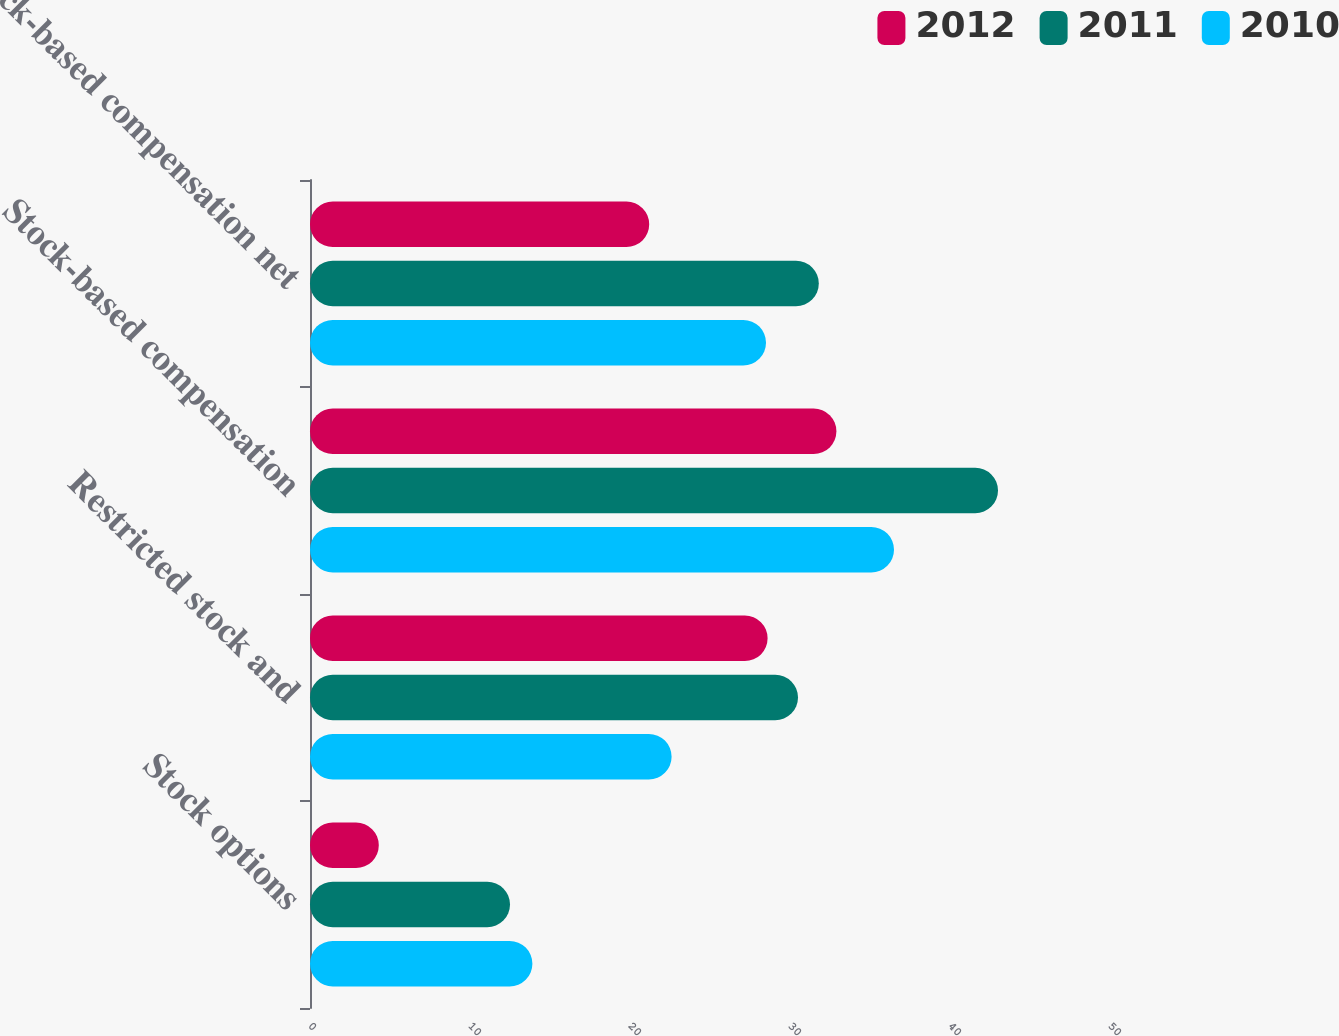Convert chart to OTSL. <chart><loc_0><loc_0><loc_500><loc_500><stacked_bar_chart><ecel><fcel>Stock options<fcel>Restricted stock and<fcel>Stock-based compensation<fcel>Stock-based compensation net<nl><fcel>2012<fcel>4.3<fcel>28.6<fcel>32.9<fcel>21.2<nl><fcel>2011<fcel>12.5<fcel>30.5<fcel>43<fcel>31.8<nl><fcel>2010<fcel>13.9<fcel>22.6<fcel>36.5<fcel>28.5<nl></chart> 